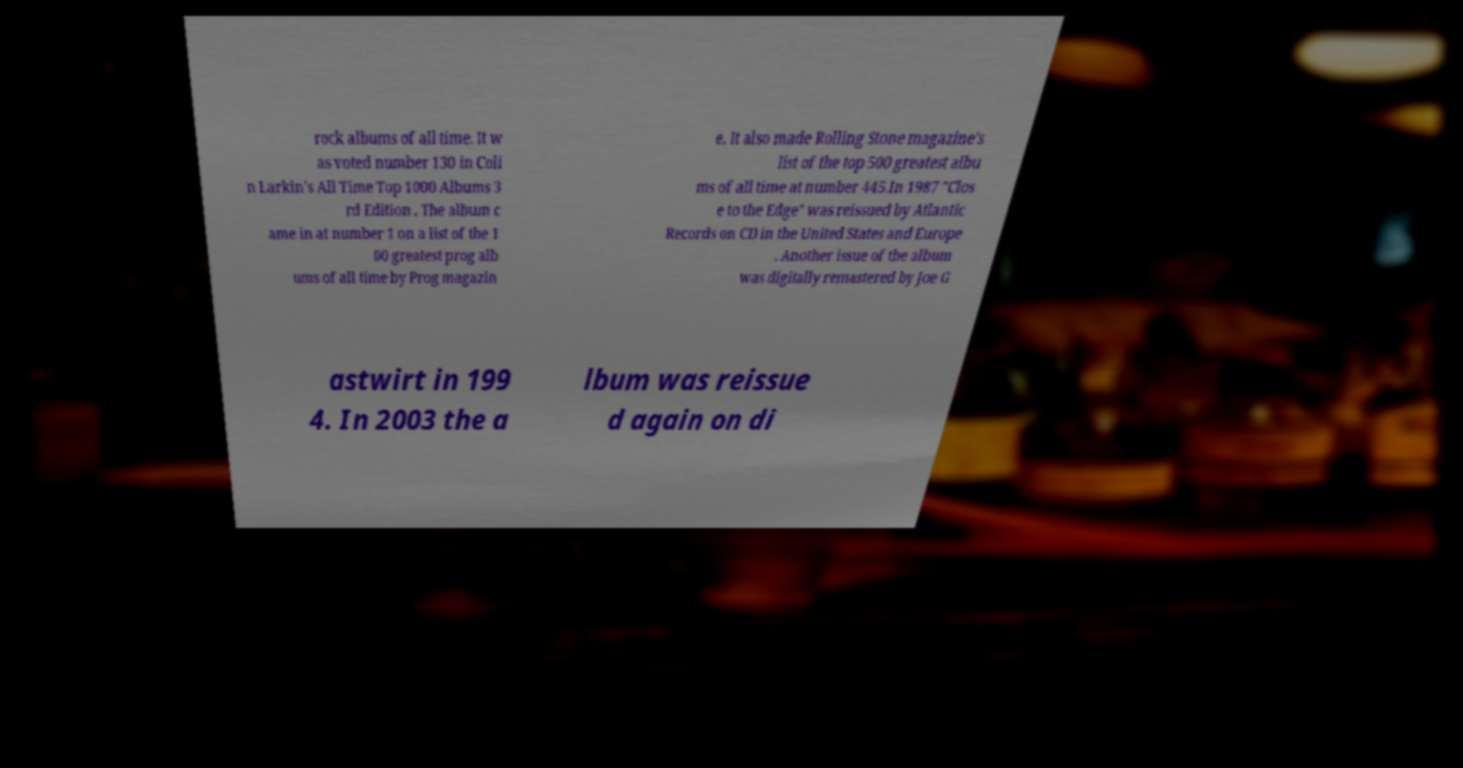For documentation purposes, I need the text within this image transcribed. Could you provide that? rock albums of all time. It w as voted number 130 in Coli n Larkin's All Time Top 1000 Albums 3 rd Edition . The album c ame in at number 1 on a list of the 1 00 greatest prog alb ums of all time by Prog magazin e. It also made Rolling Stone magazine's list of the top 500 greatest albu ms of all time at number 445.In 1987 "Clos e to the Edge" was reissued by Atlantic Records on CD in the United States and Europe . Another issue of the album was digitally remastered by Joe G astwirt in 199 4. In 2003 the a lbum was reissue d again on di 